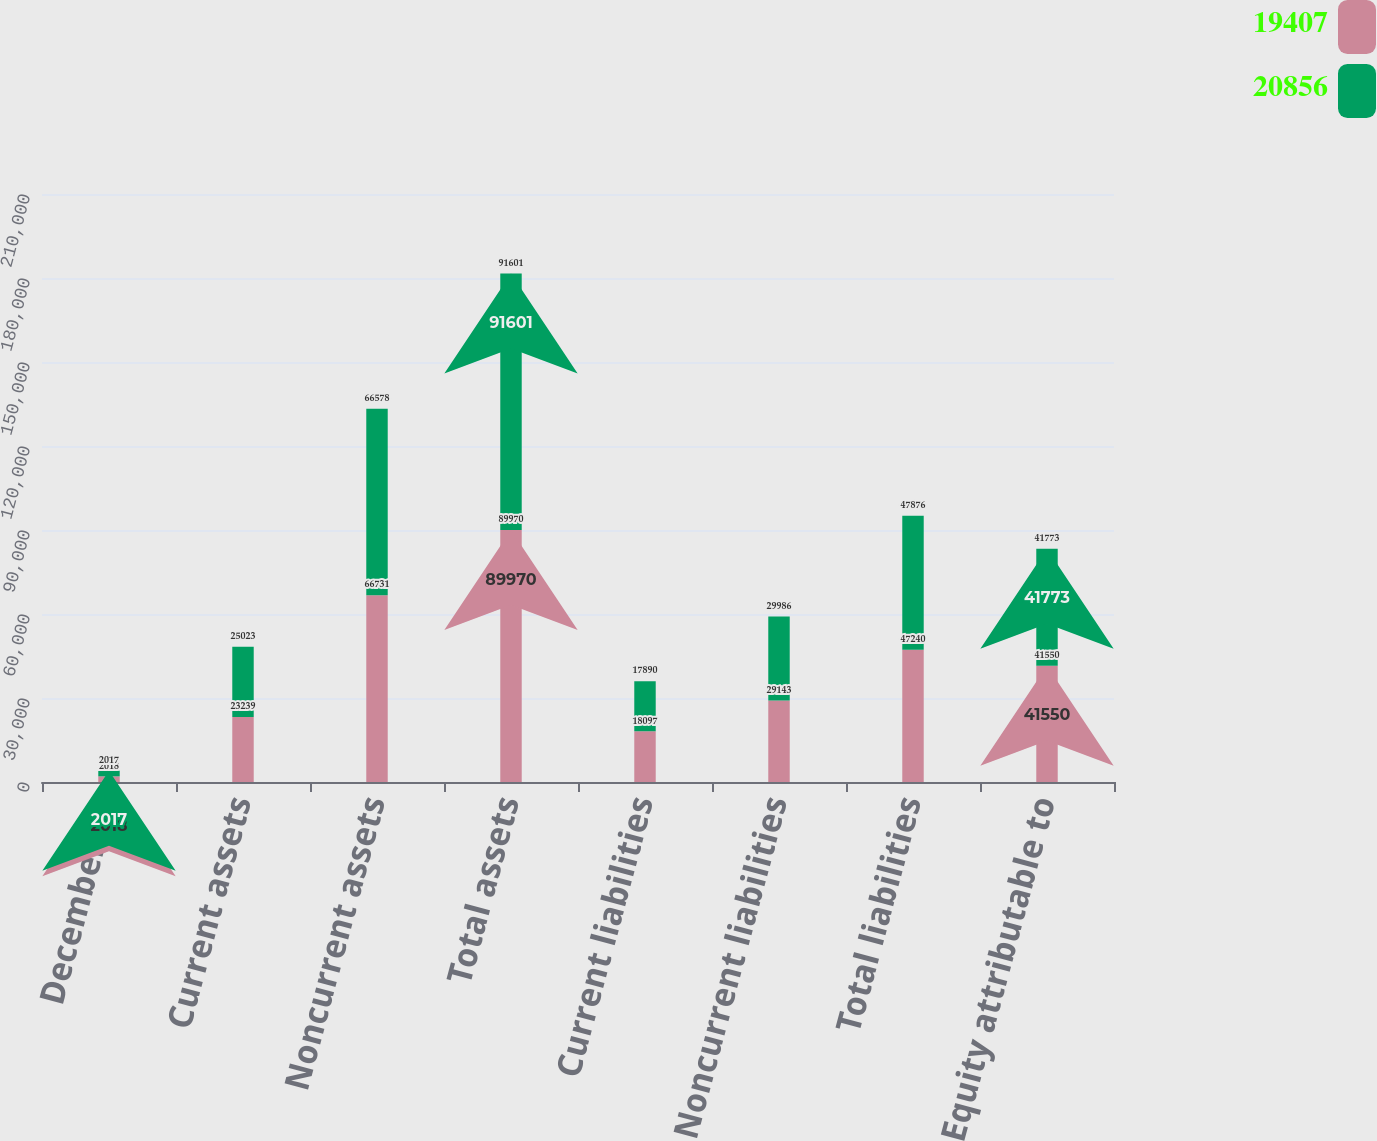Convert chart to OTSL. <chart><loc_0><loc_0><loc_500><loc_500><stacked_bar_chart><ecel><fcel>December 31<fcel>Current assets<fcel>Noncurrent assets<fcel>Total assets<fcel>Current liabilities<fcel>Noncurrent liabilities<fcel>Total liabilities<fcel>Equity attributable to<nl><fcel>19407<fcel>2018<fcel>23239<fcel>66731<fcel>89970<fcel>18097<fcel>29143<fcel>47240<fcel>41550<nl><fcel>20856<fcel>2017<fcel>25023<fcel>66578<fcel>91601<fcel>17890<fcel>29986<fcel>47876<fcel>41773<nl></chart> 